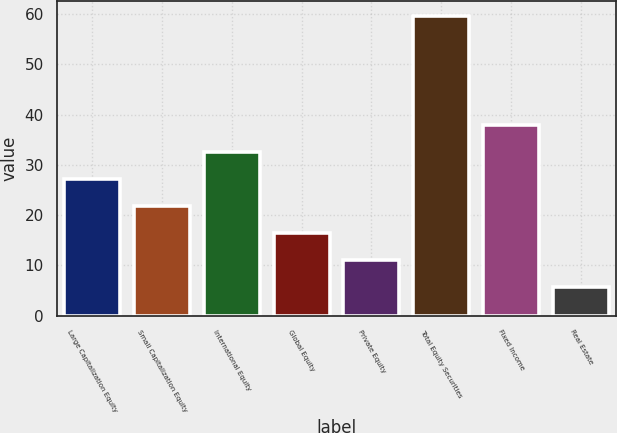Convert chart to OTSL. <chart><loc_0><loc_0><loc_500><loc_500><bar_chart><fcel>Large Capitalization Equity<fcel>Small Capitalization Equity<fcel>International Equity<fcel>Global Equity<fcel>Private Equity<fcel>Total Equity Securities<fcel>Fixed Income<fcel>Real Estate<nl><fcel>27.22<fcel>21.84<fcel>32.6<fcel>16.46<fcel>11.08<fcel>59.5<fcel>37.98<fcel>5.7<nl></chart> 